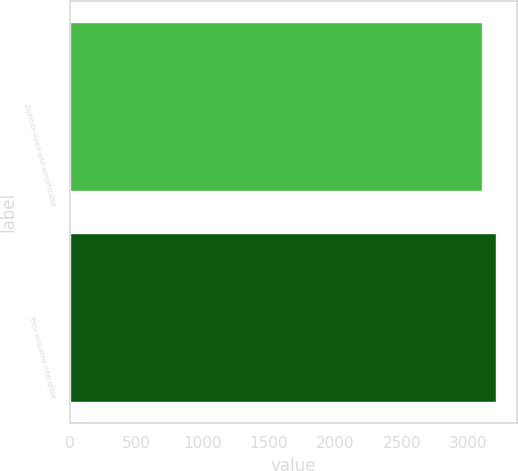<chart> <loc_0><loc_0><loc_500><loc_500><bar_chart><fcel>Definite-lived and amortizable<fcel>Total acquired intangible<nl><fcel>3106<fcel>3206<nl></chart> 